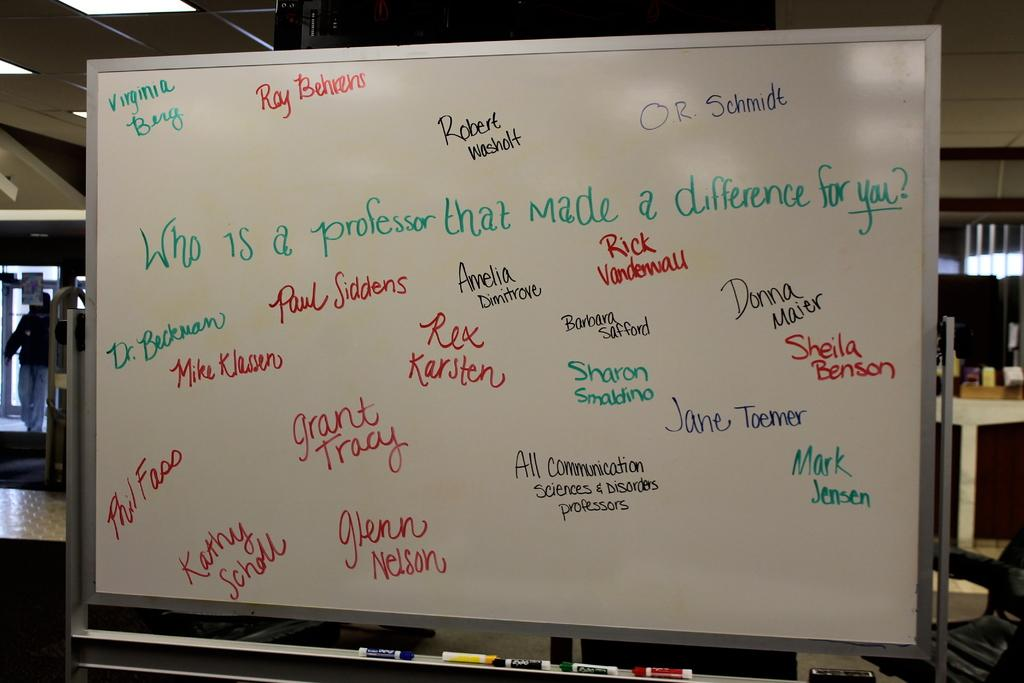Provide a one-sentence caption for the provided image. A dry erase board that has mutiple names on it. 